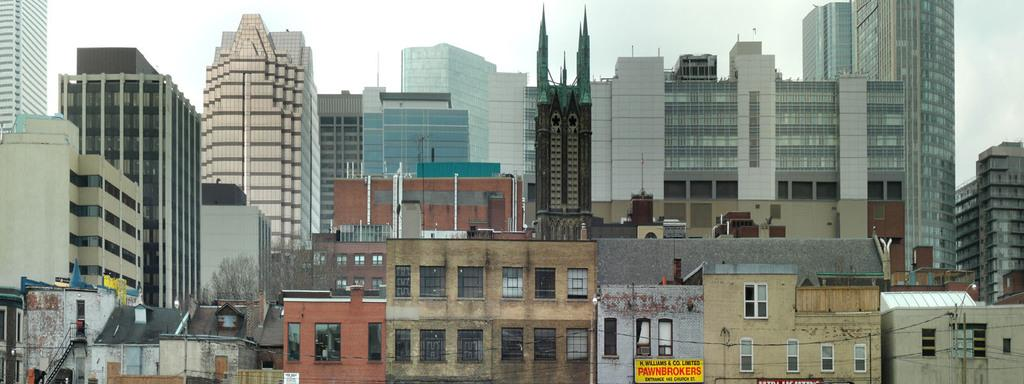<image>
Write a terse but informative summary of the picture. a pawnbrokers sign that is in a city setting 